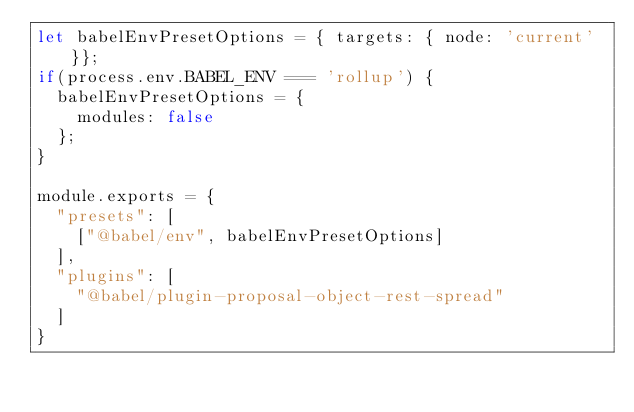Convert code to text. <code><loc_0><loc_0><loc_500><loc_500><_JavaScript_>let babelEnvPresetOptions = { targets: { node: 'current' }};
if(process.env.BABEL_ENV === 'rollup') {
  babelEnvPresetOptions = {
    modules: false
  };
}

module.exports = {
  "presets": [
    ["@babel/env", babelEnvPresetOptions]
  ],
  "plugins": [
    "@babel/plugin-proposal-object-rest-spread"
  ]
}</code> 